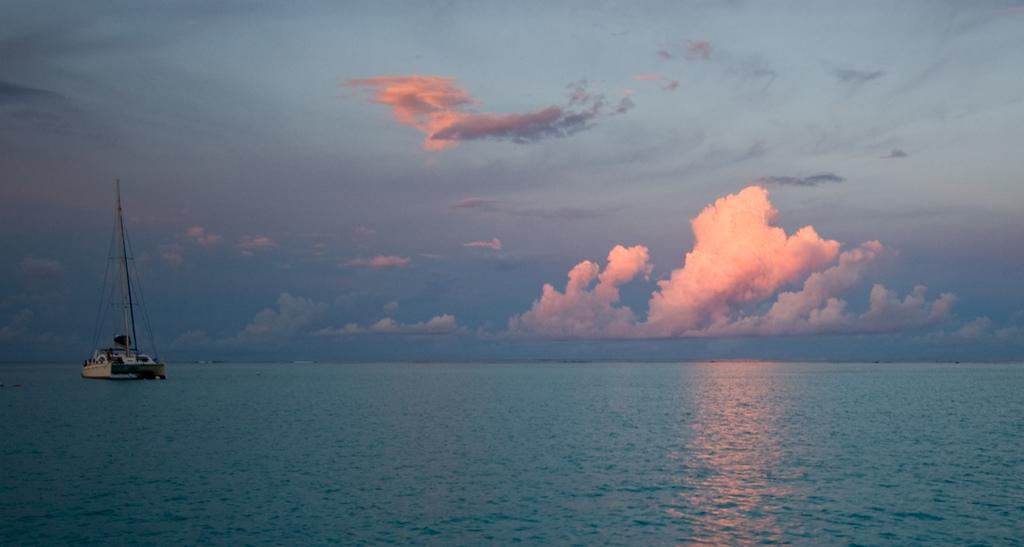What is the main subject of the image? The main subject of the image is a boat. Where is the boat located in the image? The boat is in the ocean and on the left side of the image. What can be seen in the sky in the image? The sky is visible in the image, and there are clouds present. What rule does the nation enforce regarding the boat in the image? There is no mention of a nation or any rules in the image, so we cannot determine any rules related to the boat. 